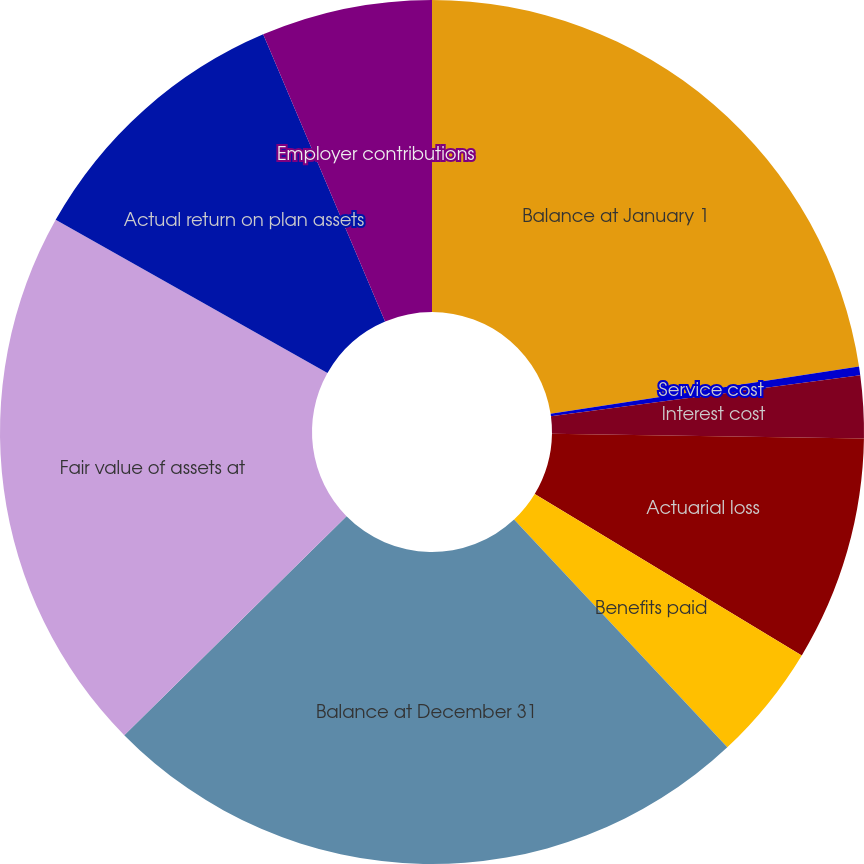<chart> <loc_0><loc_0><loc_500><loc_500><pie_chart><fcel>Balance at January 1<fcel>Service cost<fcel>Interest cost<fcel>Actuarial loss<fcel>Benefits paid<fcel>Balance at December 31<fcel>Fair value of assets at<fcel>Actual return on plan assets<fcel>Employer contributions<nl><fcel>22.58%<fcel>0.32%<fcel>2.34%<fcel>8.41%<fcel>4.37%<fcel>24.6%<fcel>20.55%<fcel>10.44%<fcel>6.39%<nl></chart> 